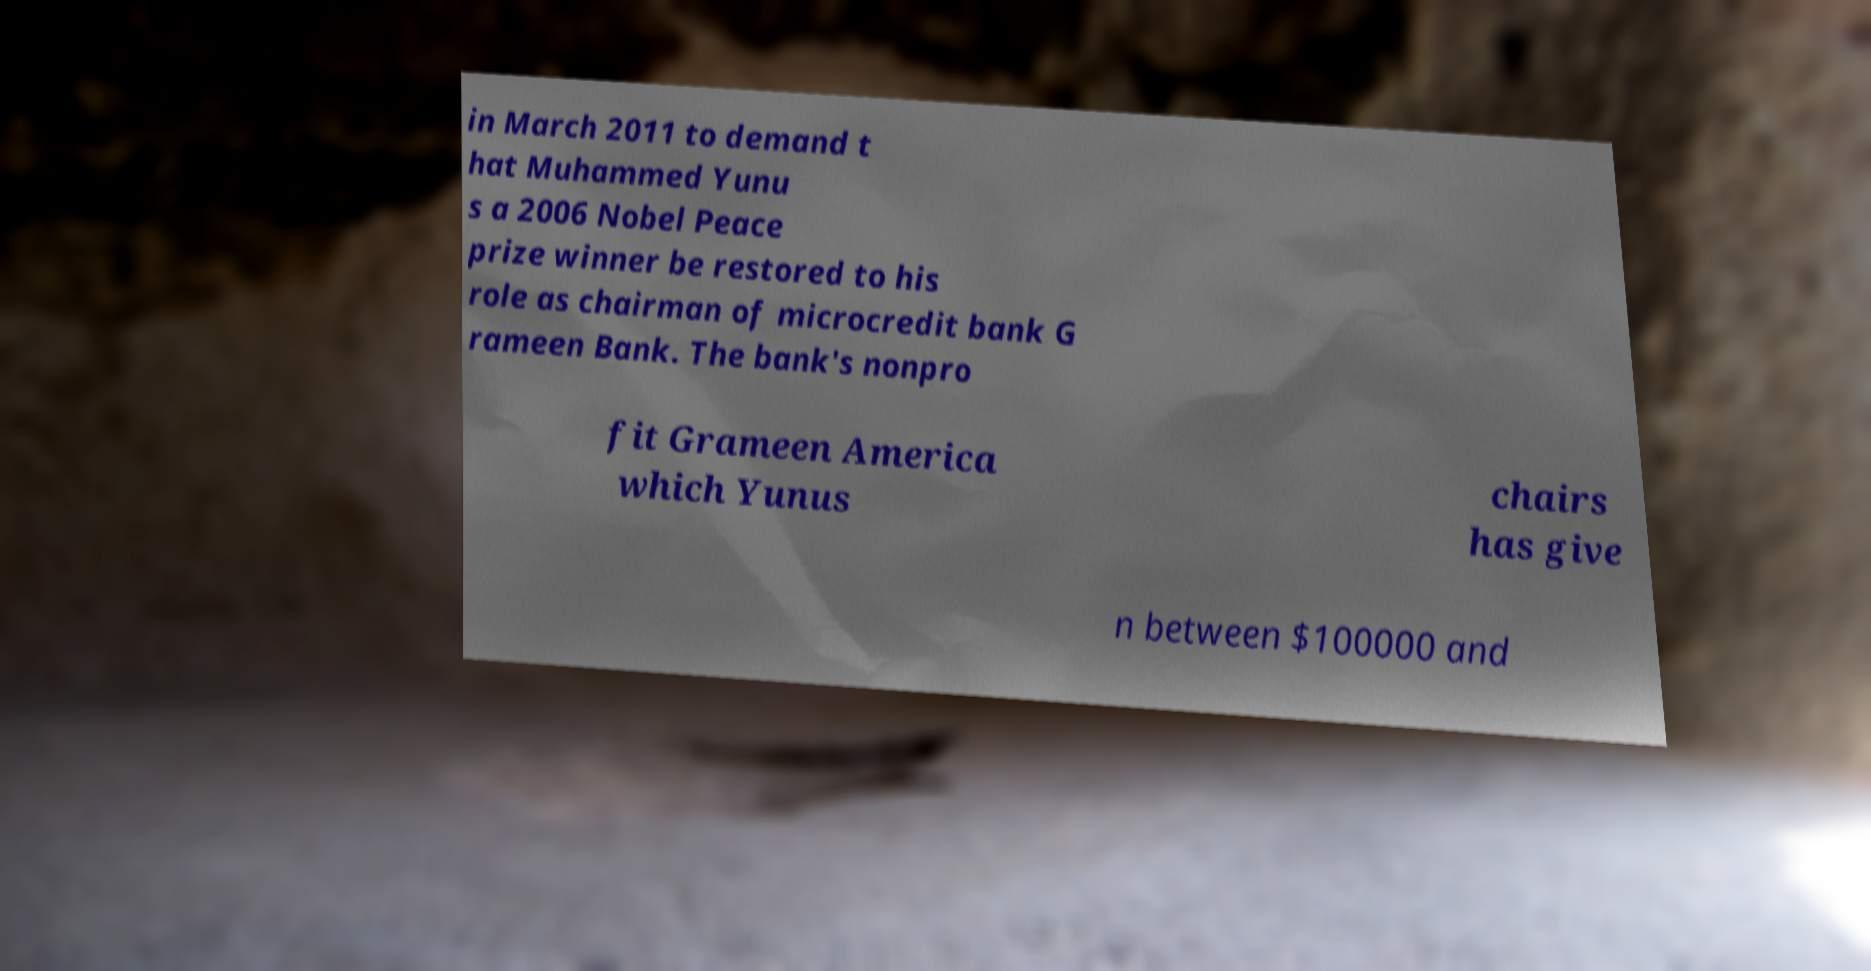I need the written content from this picture converted into text. Can you do that? in March 2011 to demand t hat Muhammed Yunu s a 2006 Nobel Peace prize winner be restored to his role as chairman of microcredit bank G rameen Bank. The bank's nonpro fit Grameen America which Yunus chairs has give n between $100000 and 